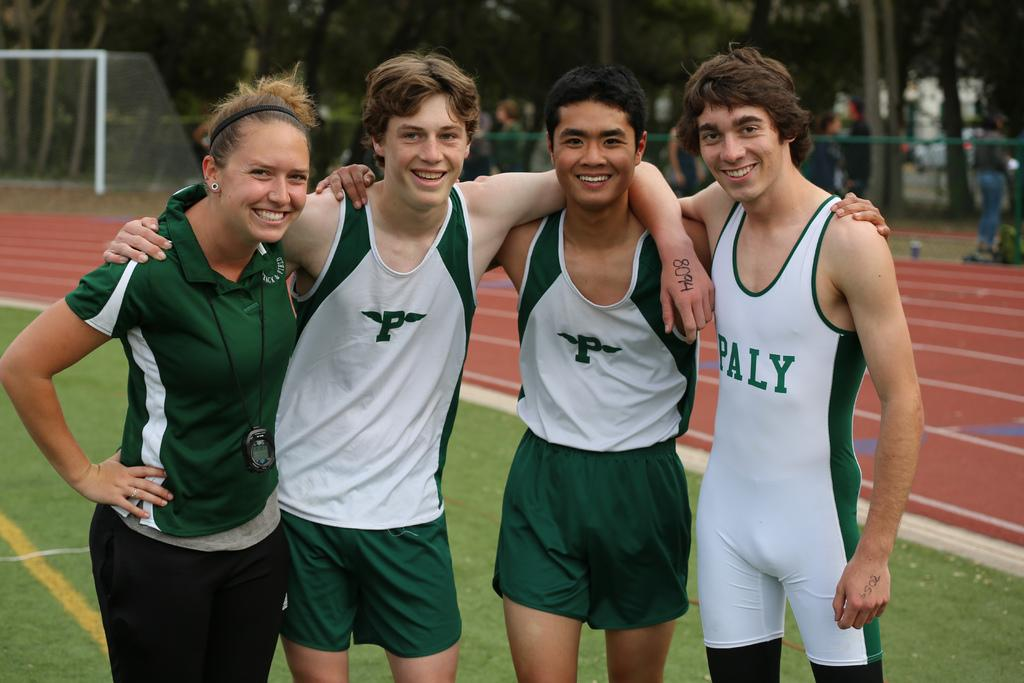<image>
Summarize the visual content of the image. Three boys and a female pose for their picture together wearing clothes that either have P or Paly on them. 